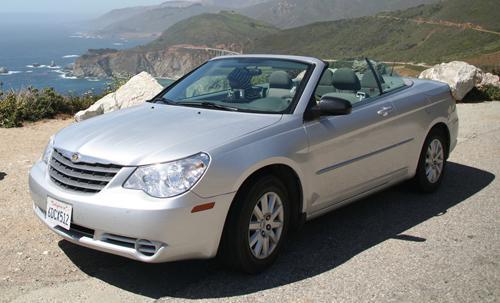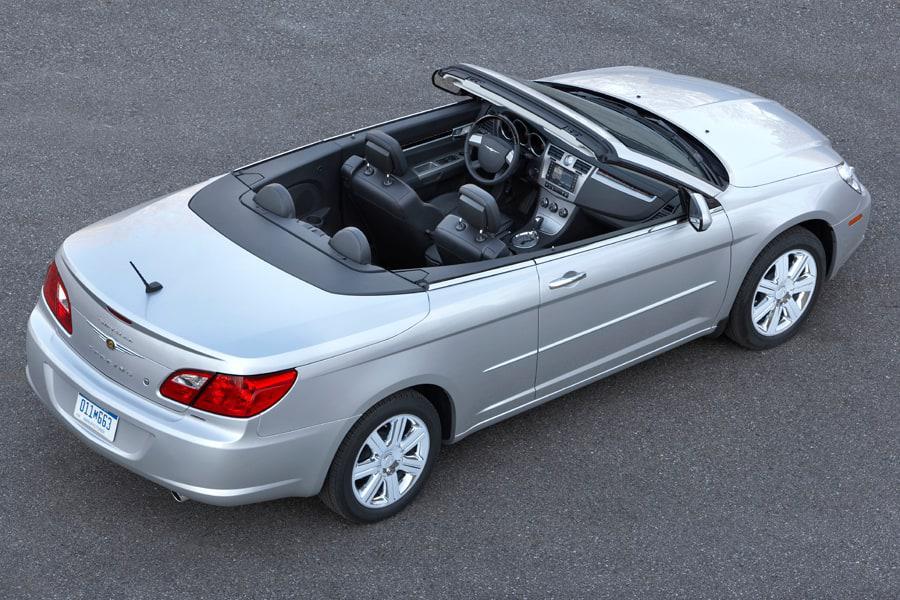The first image is the image on the left, the second image is the image on the right. For the images shown, is this caption "Both images contain a red convertible automobile." true? Answer yes or no. No. 